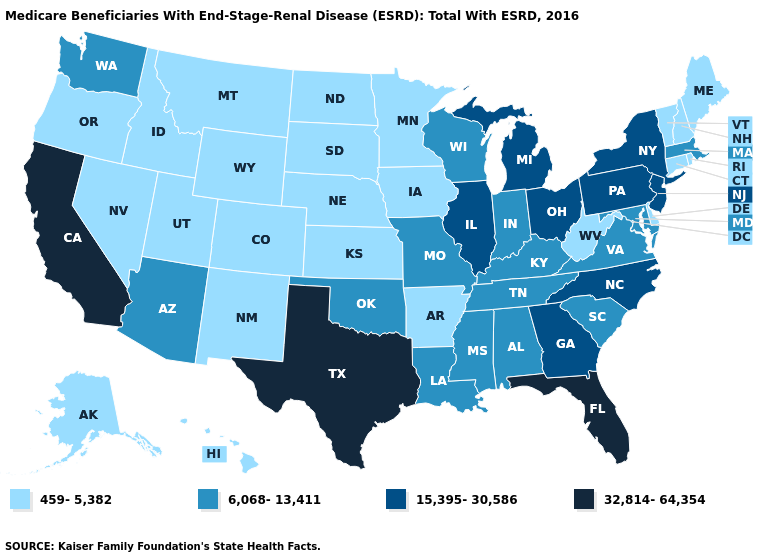Among the states that border Utah , which have the lowest value?
Quick response, please. Colorado, Idaho, Nevada, New Mexico, Wyoming. What is the lowest value in the Northeast?
Be succinct. 459-5,382. Which states have the highest value in the USA?
Answer briefly. California, Florida, Texas. Does Idaho have the lowest value in the USA?
Keep it brief. Yes. What is the value of Nevada?
Quick response, please. 459-5,382. Which states have the lowest value in the USA?
Write a very short answer. Alaska, Arkansas, Colorado, Connecticut, Delaware, Hawaii, Idaho, Iowa, Kansas, Maine, Minnesota, Montana, Nebraska, Nevada, New Hampshire, New Mexico, North Dakota, Oregon, Rhode Island, South Dakota, Utah, Vermont, West Virginia, Wyoming. Name the states that have a value in the range 32,814-64,354?
Answer briefly. California, Florida, Texas. How many symbols are there in the legend?
Be succinct. 4. What is the value of Kansas?
Be succinct. 459-5,382. Name the states that have a value in the range 32,814-64,354?
Short answer required. California, Florida, Texas. Which states have the lowest value in the Northeast?
Quick response, please. Connecticut, Maine, New Hampshire, Rhode Island, Vermont. Among the states that border Nebraska , does South Dakota have the lowest value?
Concise answer only. Yes. Does Nebraska have a higher value than Hawaii?
Answer briefly. No. Does Florida have the highest value in the South?
Answer briefly. Yes. What is the value of Nebraska?
Be succinct. 459-5,382. 